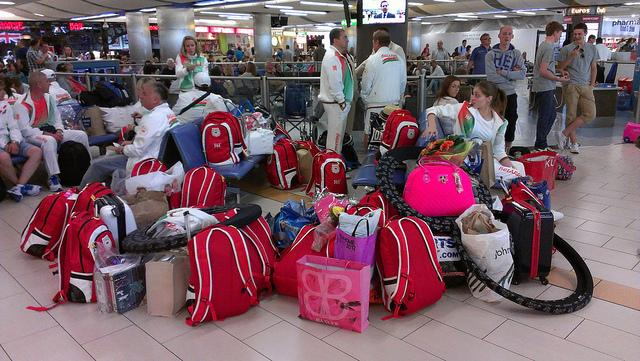Where is this scene taking place?

Choices:
A) airport
B) mall
C) dmv
D) school airport 